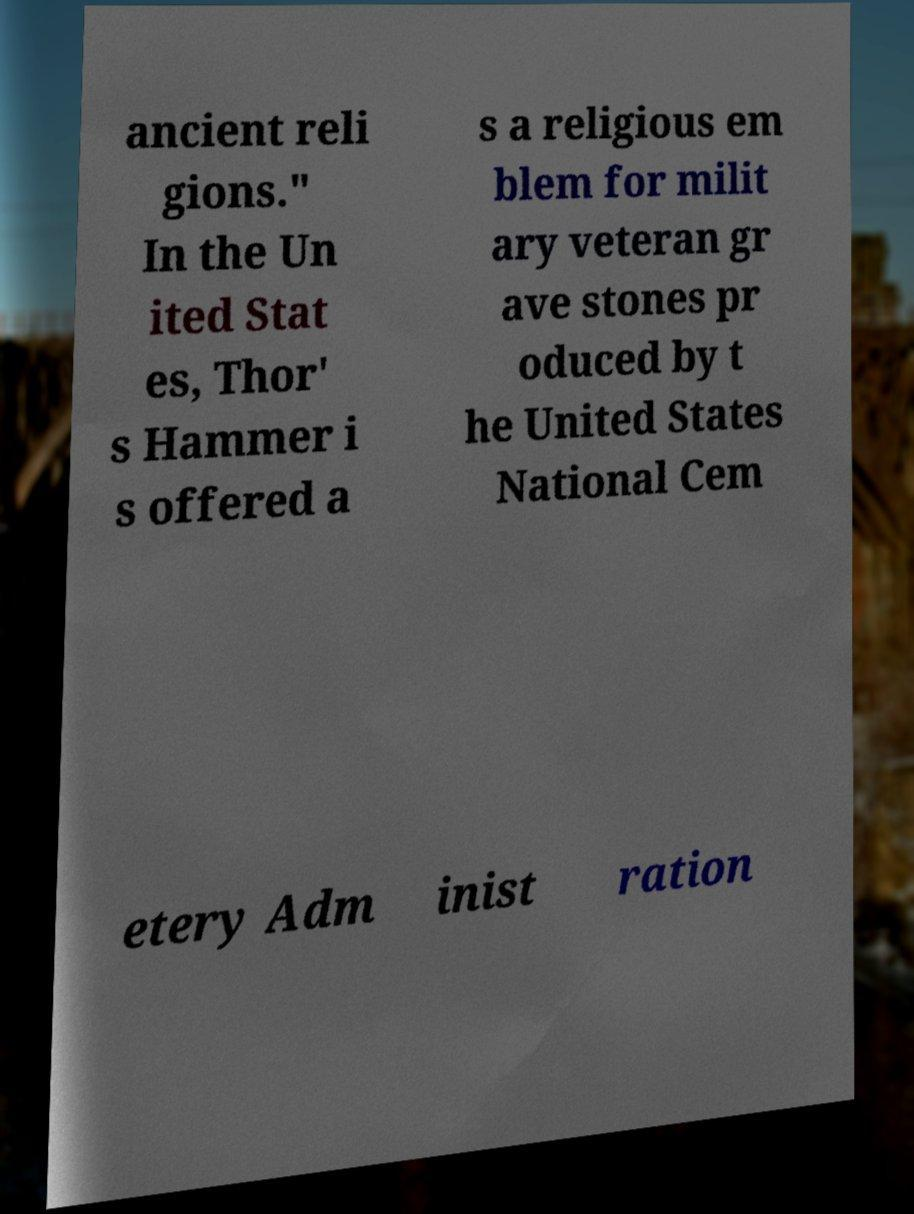Can you read and provide the text displayed in the image?This photo seems to have some interesting text. Can you extract and type it out for me? ancient reli gions." In the Un ited Stat es, Thor' s Hammer i s offered a s a religious em blem for milit ary veteran gr ave stones pr oduced by t he United States National Cem etery Adm inist ration 